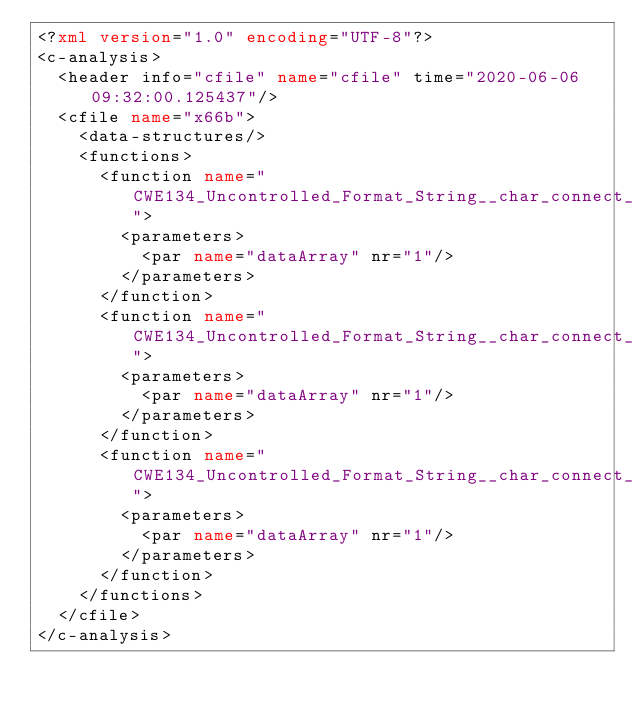<code> <loc_0><loc_0><loc_500><loc_500><_XML_><?xml version="1.0" encoding="UTF-8"?>
<c-analysis>
  <header info="cfile" name="cfile" time="2020-06-06 09:32:00.125437"/>
  <cfile name="x66b">
    <data-structures/>
    <functions>
      <function name="CWE134_Uncontrolled_Format_String__char_connect_socket_fprintf_66b_badSink">
        <parameters>
          <par name="dataArray" nr="1"/>
        </parameters>
      </function>
      <function name="CWE134_Uncontrolled_Format_String__char_connect_socket_fprintf_66b_goodB2GSink">
        <parameters>
          <par name="dataArray" nr="1"/>
        </parameters>
      </function>
      <function name="CWE134_Uncontrolled_Format_String__char_connect_socket_fprintf_66b_goodG2BSink">
        <parameters>
          <par name="dataArray" nr="1"/>
        </parameters>
      </function>
    </functions>
  </cfile>
</c-analysis>
</code> 